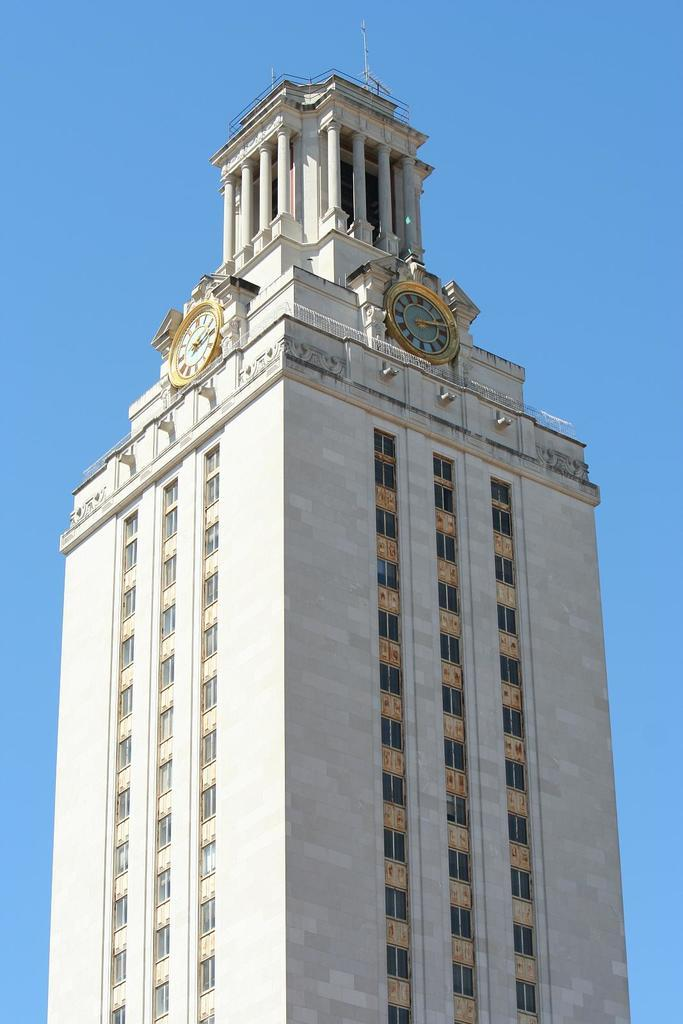What is the main subject of the image? The main subject of the image is a clock tower. Can you describe the color of the clock tower? The clock tower has a white and golden color. How big is the clock tower in the image? The clock tower is big. Where is the clock tower located in the image? The clock tower is in the middle of the image. What can be seen in the background of the image? There is a blue color sky in the background of the image. What type of teaching material is hanging from the clock tower in the image? There is no teaching material or any indication of teaching in the image; it features a clock tower with a white and golden color. What is the clock tower made of, and does it have a brass finish? The provided facts do not mention the material or finish of the clock tower, so it cannot be determined from the image. 